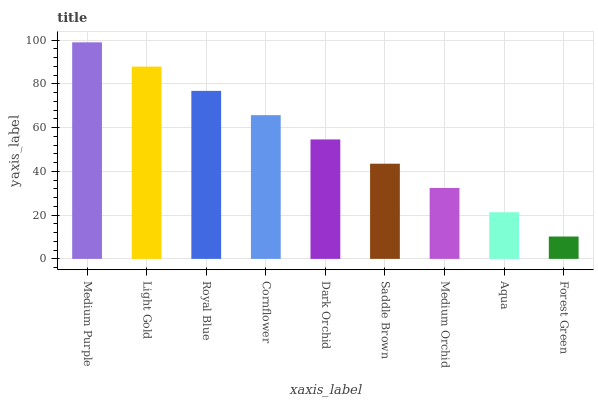Is Forest Green the minimum?
Answer yes or no. Yes. Is Medium Purple the maximum?
Answer yes or no. Yes. Is Light Gold the minimum?
Answer yes or no. No. Is Light Gold the maximum?
Answer yes or no. No. Is Medium Purple greater than Light Gold?
Answer yes or no. Yes. Is Light Gold less than Medium Purple?
Answer yes or no. Yes. Is Light Gold greater than Medium Purple?
Answer yes or no. No. Is Medium Purple less than Light Gold?
Answer yes or no. No. Is Dark Orchid the high median?
Answer yes or no. Yes. Is Dark Orchid the low median?
Answer yes or no. Yes. Is Light Gold the high median?
Answer yes or no. No. Is Aqua the low median?
Answer yes or no. No. 